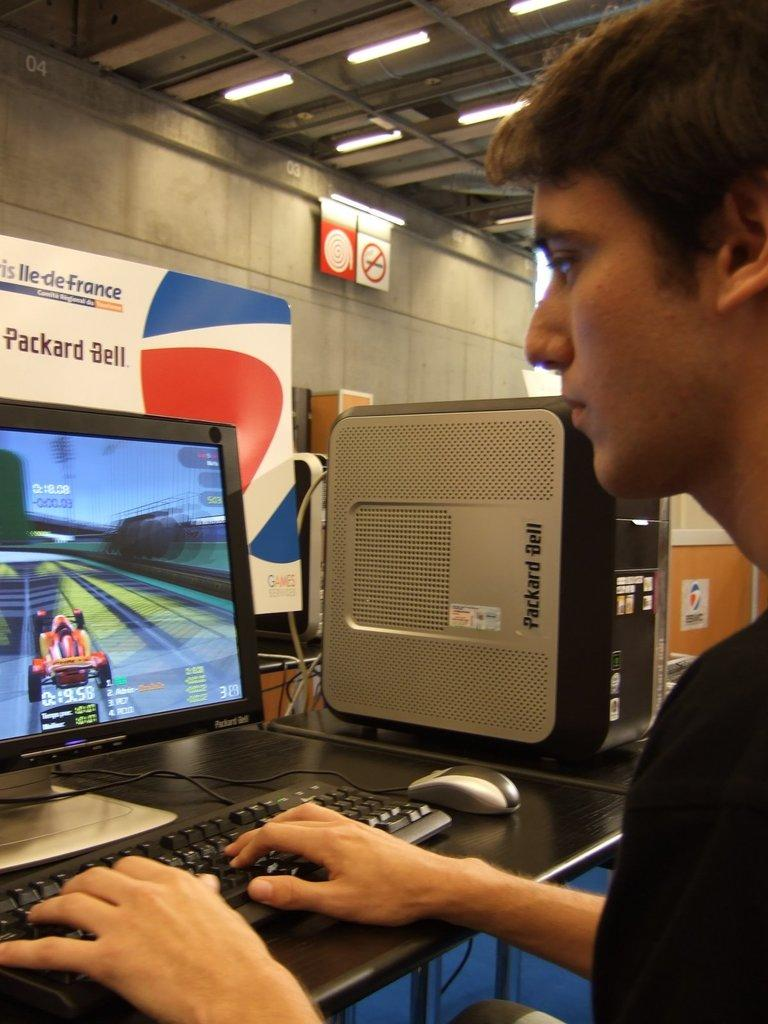<image>
Render a clear and concise summary of the photo. a boy is playing on a computer with a packard bell sign in front of him 